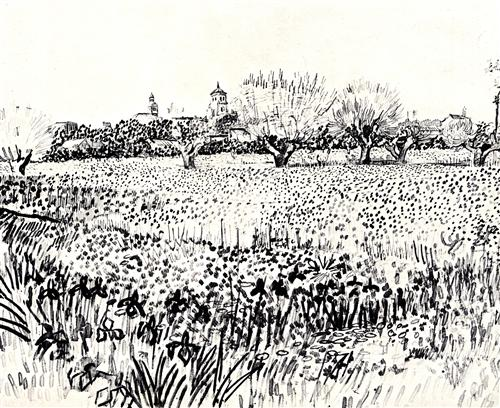If the landscape in this sketch could make a sound, what would it be? The landscape might emit a symphony of gentle, rustling grasses and the tranquil hum of a light breeze weaving through the wildflowers. Imagine the distant chirping of birds from the treetops, occasionally interrupted by the sound of leaves fluttering under the soft wind—a harmonious blend that evokes peace and natural beauty. 